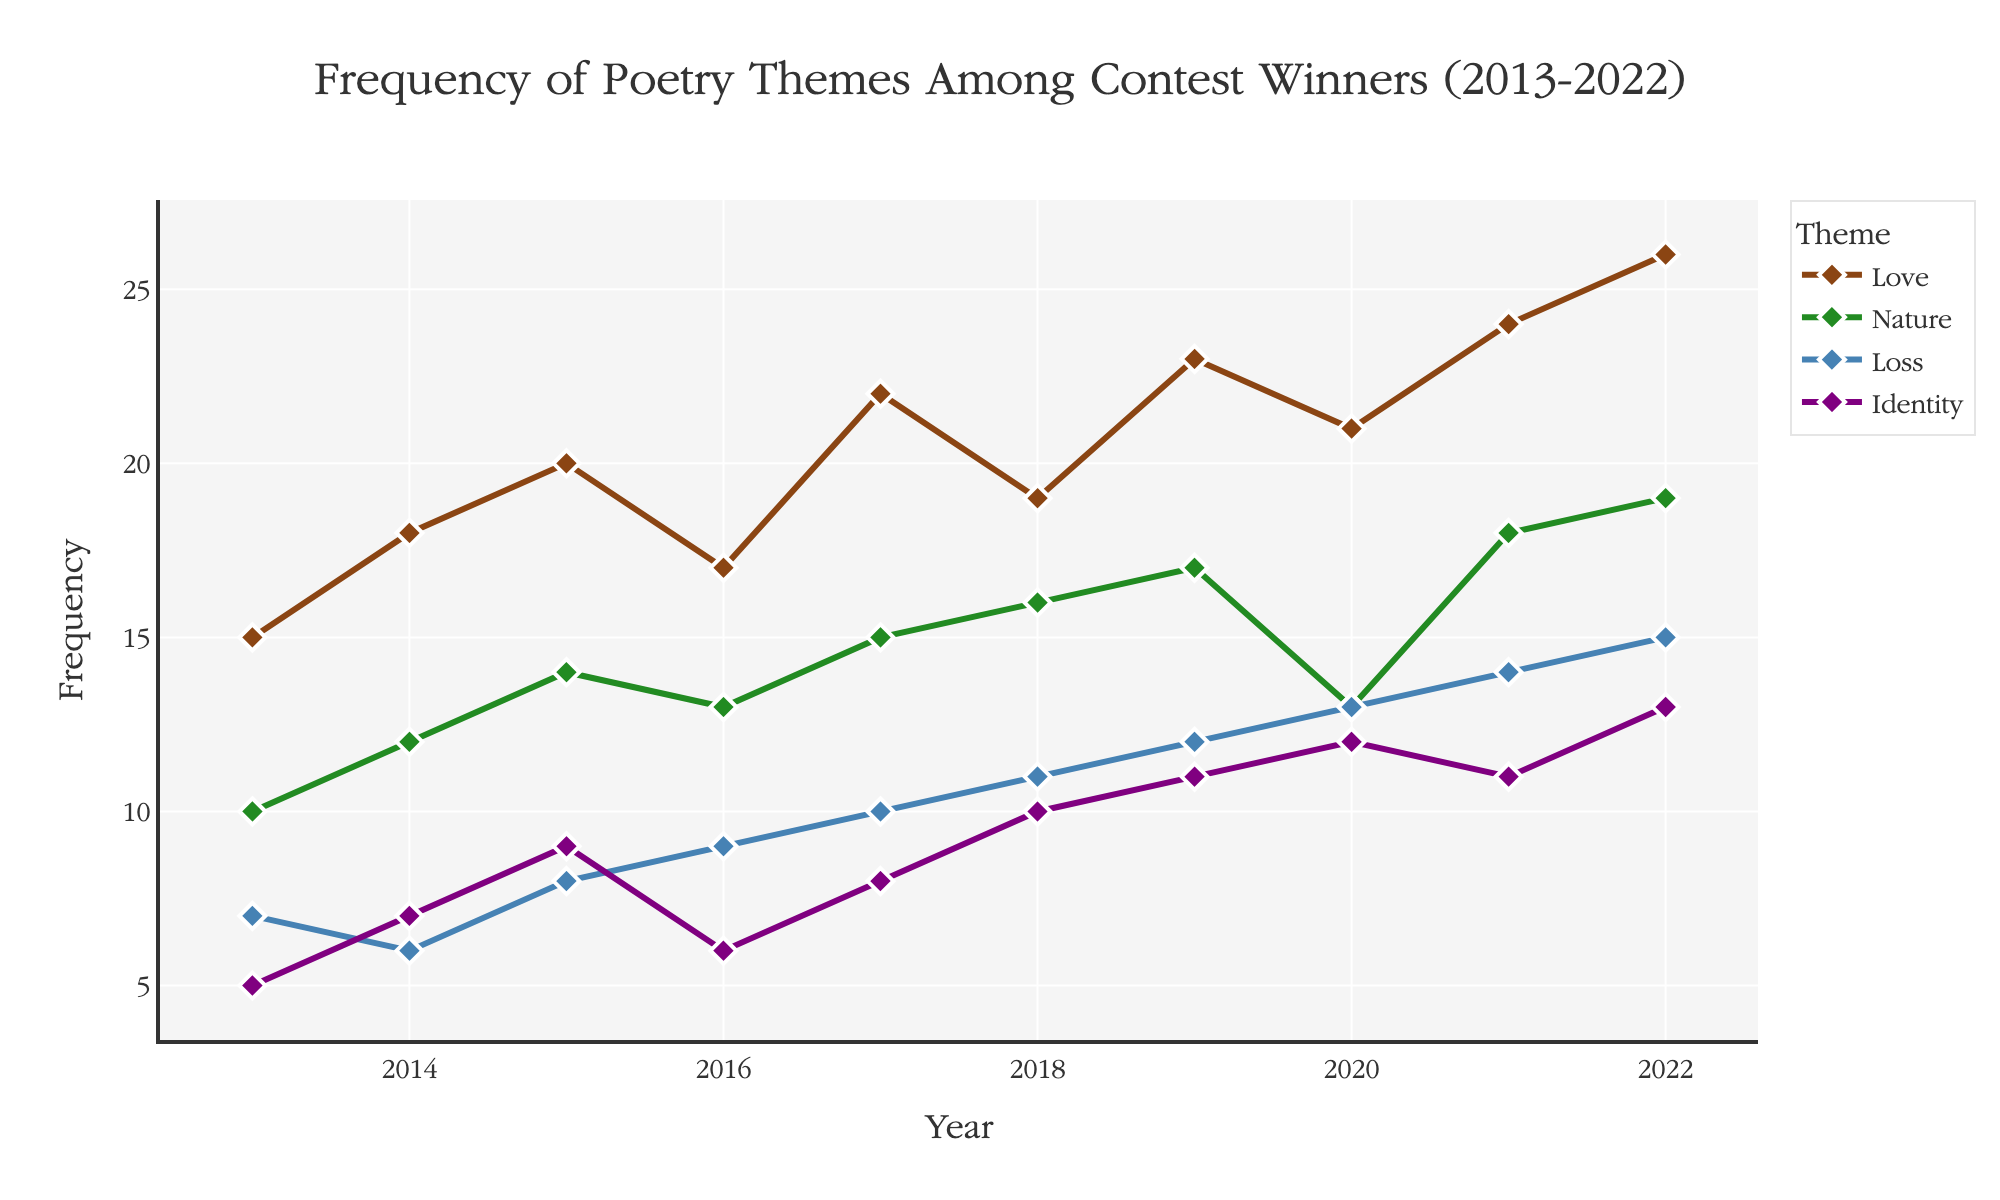What's the main theme title of the figure? The title is prominently displayed at the top of the plot and usually provides an overall description of the data being presented.
Answer: Frequency of Poetry Themes Among Contest Winners (2013-2022) How frequent was the "Love" theme in 2020? Locate the "Love" theme line, follow it to the year 2020, and note the frequency.
Answer: 21 Which year had the highest frequency of the "Nature" theme? Identify the maximum y-value for the "Nature" theme line and trace it back to the corresponding x-axis year.
Answer: 2022 What is the difference in frequency between the "Love" and "Identity" themes in 2021? Find the data points for both "Love" and "Identity" in 2021 and subtract the frequency of "Identity" from the frequency of "Love".
Answer: 24 - 11 = 13 What trend can you observe for the "Loss" theme from 2013 to 2022? Follow the "Loss" theme line from the beginning to the end of the plot, noting any increases, decreases, or patterns.
Answer: An overall increasing trend By how much did the frequency of the "Identity" theme increase from 2013 to 2022? Compare the frequency of "Identity" in 2013 and 2022 and calculate the difference.
Answer: 13 - 5 = 8 Which theme had the least frequency in 2013? Check the y-values for each theme in 2013 and find the smallest value.
Answer: Identity How did the frequency of the "Love" theme change from 2018 to 2019? Look at the "Love" theme data points for 2018 and 2019 and subtract the 2018 frequency from the 2019 frequency.
Answer: 23 - 19 = 4 What can you infer about the popularity of the "Nature" theme from 2020 to 2021? Observe the change in frequency for the "Nature" theme line between 2020 and 2021.
Answer: It increased How does the frequency of the "Identity" theme in 2020 compare to its frequency in 2018? Find and compare the frequencies of the "Identity" theme in 2020 and 2018.
Answer: 12 (in 2020) is greater than 10 (in 2018) 